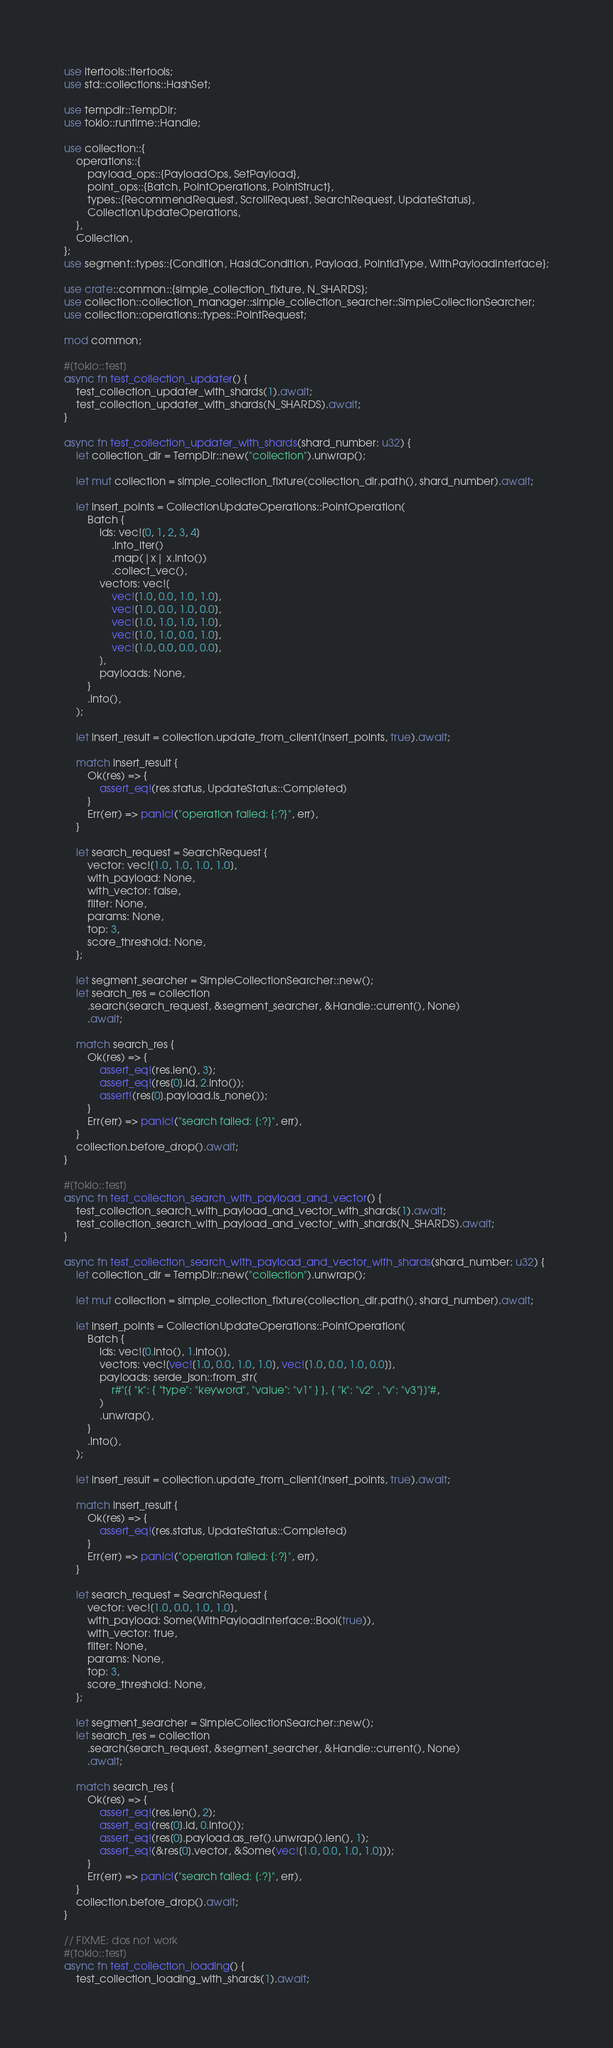<code> <loc_0><loc_0><loc_500><loc_500><_Rust_>use itertools::Itertools;
use std::collections::HashSet;

use tempdir::TempDir;
use tokio::runtime::Handle;

use collection::{
    operations::{
        payload_ops::{PayloadOps, SetPayload},
        point_ops::{Batch, PointOperations, PointStruct},
        types::{RecommendRequest, ScrollRequest, SearchRequest, UpdateStatus},
        CollectionUpdateOperations,
    },
    Collection,
};
use segment::types::{Condition, HasIdCondition, Payload, PointIdType, WithPayloadInterface};

use crate::common::{simple_collection_fixture, N_SHARDS};
use collection::collection_manager::simple_collection_searcher::SimpleCollectionSearcher;
use collection::operations::types::PointRequest;

mod common;

#[tokio::test]
async fn test_collection_updater() {
    test_collection_updater_with_shards(1).await;
    test_collection_updater_with_shards(N_SHARDS).await;
}

async fn test_collection_updater_with_shards(shard_number: u32) {
    let collection_dir = TempDir::new("collection").unwrap();

    let mut collection = simple_collection_fixture(collection_dir.path(), shard_number).await;

    let insert_points = CollectionUpdateOperations::PointOperation(
        Batch {
            ids: vec![0, 1, 2, 3, 4]
                .into_iter()
                .map(|x| x.into())
                .collect_vec(),
            vectors: vec![
                vec![1.0, 0.0, 1.0, 1.0],
                vec![1.0, 0.0, 1.0, 0.0],
                vec![1.0, 1.0, 1.0, 1.0],
                vec![1.0, 1.0, 0.0, 1.0],
                vec![1.0, 0.0, 0.0, 0.0],
            ],
            payloads: None,
        }
        .into(),
    );

    let insert_result = collection.update_from_client(insert_points, true).await;

    match insert_result {
        Ok(res) => {
            assert_eq!(res.status, UpdateStatus::Completed)
        }
        Err(err) => panic!("operation failed: {:?}", err),
    }

    let search_request = SearchRequest {
        vector: vec![1.0, 1.0, 1.0, 1.0],
        with_payload: None,
        with_vector: false,
        filter: None,
        params: None,
        top: 3,
        score_threshold: None,
    };

    let segment_searcher = SimpleCollectionSearcher::new();
    let search_res = collection
        .search(search_request, &segment_searcher, &Handle::current(), None)
        .await;

    match search_res {
        Ok(res) => {
            assert_eq!(res.len(), 3);
            assert_eq!(res[0].id, 2.into());
            assert!(res[0].payload.is_none());
        }
        Err(err) => panic!("search failed: {:?}", err),
    }
    collection.before_drop().await;
}

#[tokio::test]
async fn test_collection_search_with_payload_and_vector() {
    test_collection_search_with_payload_and_vector_with_shards(1).await;
    test_collection_search_with_payload_and_vector_with_shards(N_SHARDS).await;
}

async fn test_collection_search_with_payload_and_vector_with_shards(shard_number: u32) {
    let collection_dir = TempDir::new("collection").unwrap();

    let mut collection = simple_collection_fixture(collection_dir.path(), shard_number).await;

    let insert_points = CollectionUpdateOperations::PointOperation(
        Batch {
            ids: vec![0.into(), 1.into()],
            vectors: vec![vec![1.0, 0.0, 1.0, 1.0], vec![1.0, 0.0, 1.0, 0.0]],
            payloads: serde_json::from_str(
                r#"[{ "k": { "type": "keyword", "value": "v1" } }, { "k": "v2" , "v": "v3"}]"#,
            )
            .unwrap(),
        }
        .into(),
    );

    let insert_result = collection.update_from_client(insert_points, true).await;

    match insert_result {
        Ok(res) => {
            assert_eq!(res.status, UpdateStatus::Completed)
        }
        Err(err) => panic!("operation failed: {:?}", err),
    }

    let search_request = SearchRequest {
        vector: vec![1.0, 0.0, 1.0, 1.0],
        with_payload: Some(WithPayloadInterface::Bool(true)),
        with_vector: true,
        filter: None,
        params: None,
        top: 3,
        score_threshold: None,
    };

    let segment_searcher = SimpleCollectionSearcher::new();
    let search_res = collection
        .search(search_request, &segment_searcher, &Handle::current(), None)
        .await;

    match search_res {
        Ok(res) => {
            assert_eq!(res.len(), 2);
            assert_eq!(res[0].id, 0.into());
            assert_eq!(res[0].payload.as_ref().unwrap().len(), 1);
            assert_eq!(&res[0].vector, &Some(vec![1.0, 0.0, 1.0, 1.0]));
        }
        Err(err) => panic!("search failed: {:?}", err),
    }
    collection.before_drop().await;
}

// FIXME: dos not work
#[tokio::test]
async fn test_collection_loading() {
    test_collection_loading_with_shards(1).await;</code> 